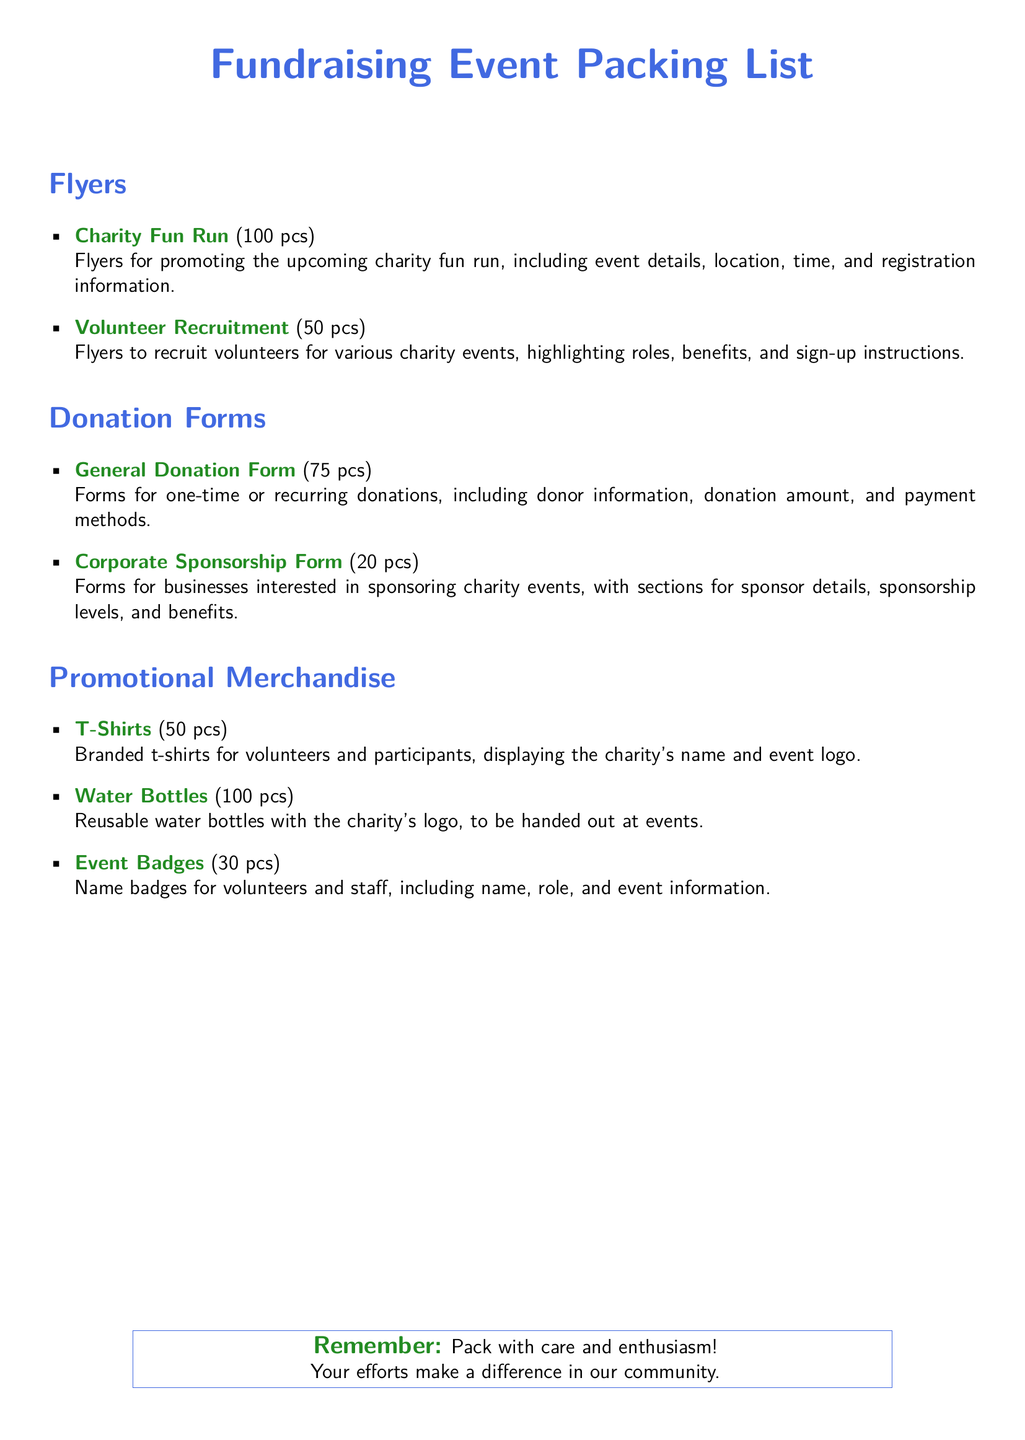What is the total number of Flyers? The total number of Flyers is the sum of all flyers listed: 100 + 50 = 150.
Answer: 150 How many Corporate Sponsorship Forms are there? The document specifies that there are 20 Corporate Sponsorship Forms.
Answer: 20 What type of event is mentioned in the Flyers section? The Flyers section highlights a specific event, which is the Charity Fun Run.
Answer: Charity Fun Run How many T-Shirts are included in the Promotional Merchandise? The total number of T-Shirts listed in the document is 50.
Answer: 50 What is the purpose of the General Donation Form? The General Donation Form is used for one-time or recurring donations, according to the description provided.
Answer: One-time or recurring donations How many types of Promotional Merchandise are listed? The document lists three different types of Promotional Merchandise: T-Shirts, Water Bottles, and Event Badges.
Answer: Three How many Donation Forms are available in total? The total number of Donation Forms is calculated by adding General Donation Forms and Corporate Sponsorship Forms: 75 + 20 = 95.
Answer: 95 What color is used for the title of the document? The title of the document uses a specific color, which is runnerblue.
Answer: runnerblue What inspirational note is included at the bottom of the document? The document ends with a motivational note that emphasizes packing with care and enthusiasm.
Answer: Pack with care and enthusiasm! 